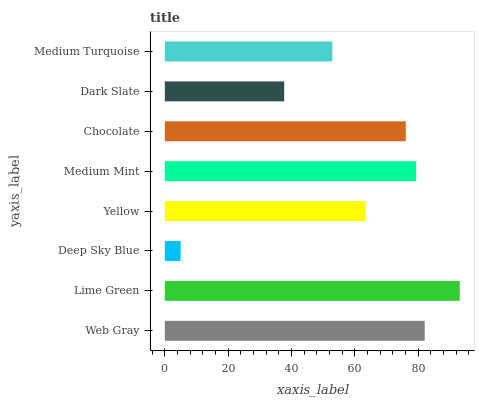Is Deep Sky Blue the minimum?
Answer yes or no. Yes. Is Lime Green the maximum?
Answer yes or no. Yes. Is Lime Green the minimum?
Answer yes or no. No. Is Deep Sky Blue the maximum?
Answer yes or no. No. Is Lime Green greater than Deep Sky Blue?
Answer yes or no. Yes. Is Deep Sky Blue less than Lime Green?
Answer yes or no. Yes. Is Deep Sky Blue greater than Lime Green?
Answer yes or no. No. Is Lime Green less than Deep Sky Blue?
Answer yes or no. No. Is Chocolate the high median?
Answer yes or no. Yes. Is Yellow the low median?
Answer yes or no. Yes. Is Medium Mint the high median?
Answer yes or no. No. Is Deep Sky Blue the low median?
Answer yes or no. No. 